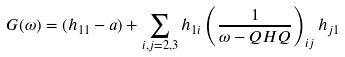<formula> <loc_0><loc_0><loc_500><loc_500>G ( \omega ) = ( h _ { 1 1 } - a ) + \sum _ { i , j = 2 , 3 } h _ { 1 i } \left ( \frac { 1 } { \omega - Q H Q } \right ) _ { i j } h _ { j 1 }</formula> 